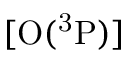Convert formula to latex. <formula><loc_0><loc_0><loc_500><loc_500>[ O ( ^ { 3 } P ) ]</formula> 